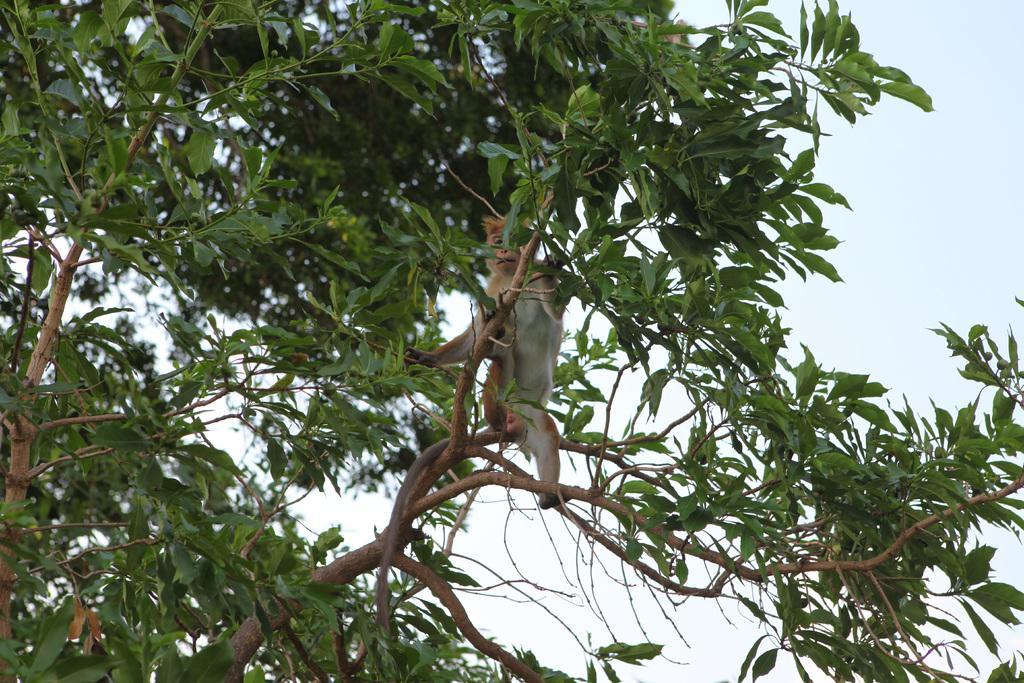In one or two sentences, can you explain what this image depicts? In this image, there are a few trees. We can see a monkey on one of the trees. We can also see the sky. 